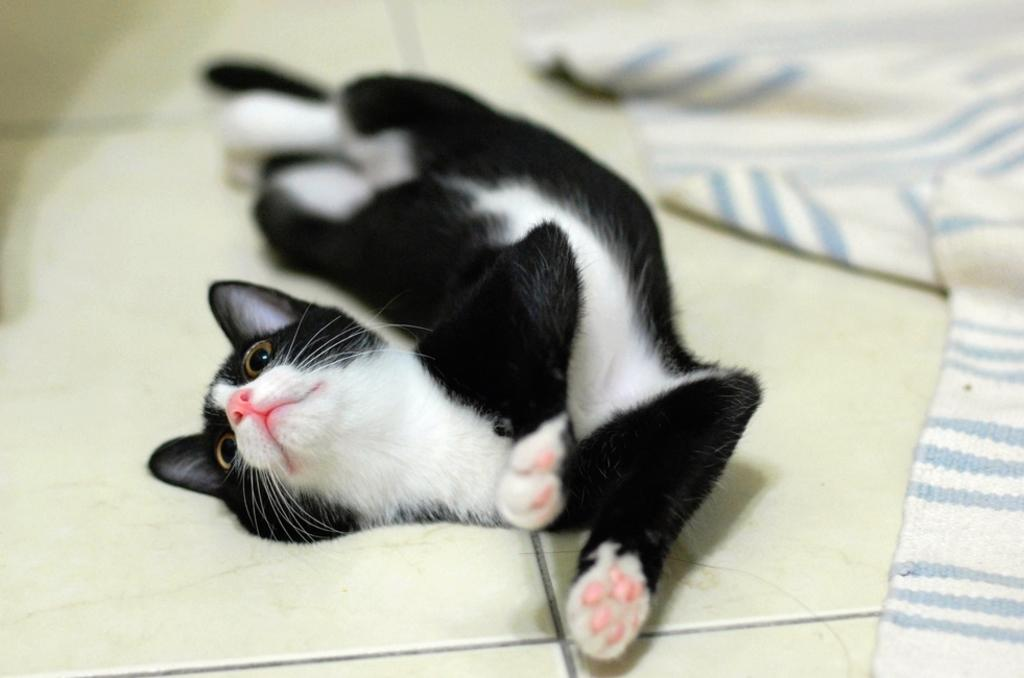What type of animal is in the image? There is a cat in the image. What is the cat doing in the image? The cat is lying on the floor. What can be seen on the right side of the image? There is a carpet on the right side of the image. What is the existence of the cat in the image trying to prove? The existence of the cat in the image is not trying to prove anything; it is simply a depiction of a cat lying on the floor. What time of day is the image set in? The time of day is not specified in the image, so it cannot be determined from the image alone. 